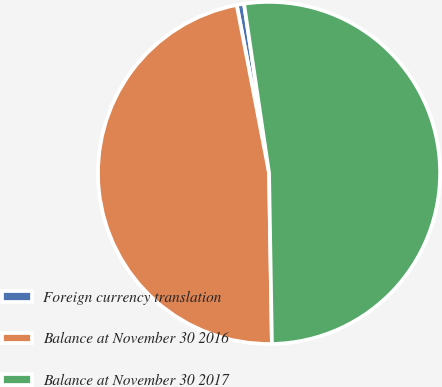<chart> <loc_0><loc_0><loc_500><loc_500><pie_chart><fcel>Foreign currency translation<fcel>Balance at November 30 2016<fcel>Balance at November 30 2017<nl><fcel>0.69%<fcel>47.24%<fcel>52.07%<nl></chart> 